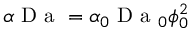Convert formula to latex. <formula><loc_0><loc_0><loc_500><loc_500>\alpha D a = \alpha _ { 0 } D a _ { 0 } \phi _ { 0 } ^ { 2 }</formula> 